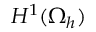<formula> <loc_0><loc_0><loc_500><loc_500>H ^ { 1 } ( \Omega _ { h } )</formula> 